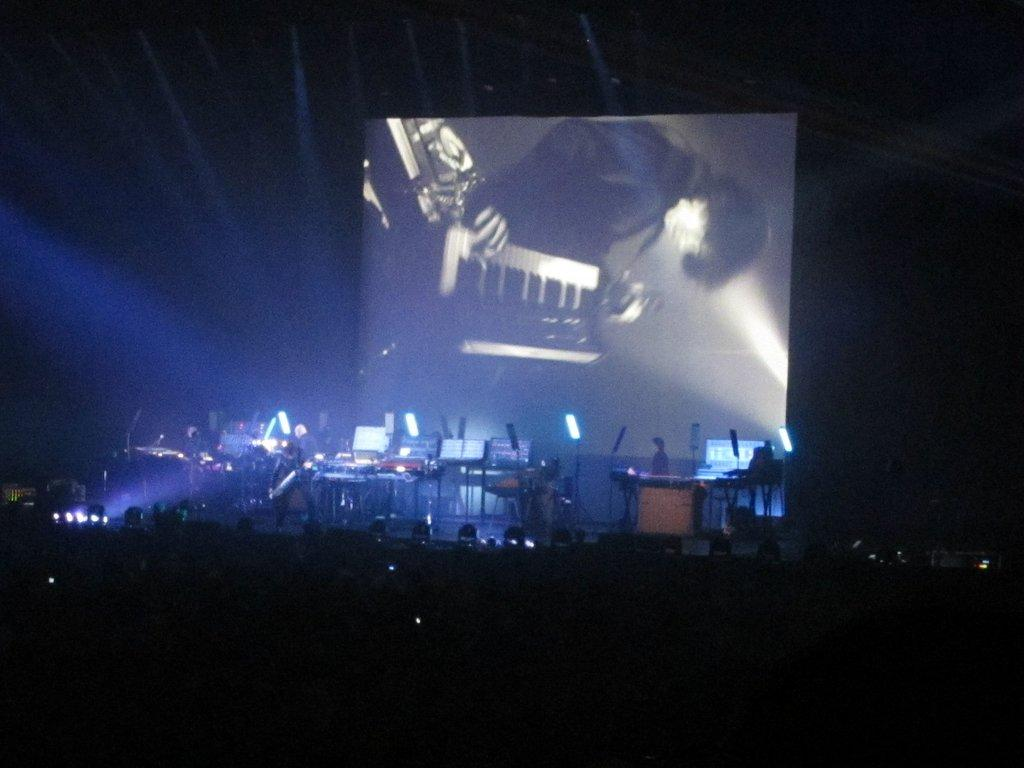What can be seen on the stage in the image? There are musical instruments on the stage in the image. Can you describe the person in the image? There is a person standing in the image. What can be seen illuminating the stage or the person? There are lights visible in the image. What is present in the background of the image? There is a screen in the background of the image. What type of van is being used for the voyage in the image? There is no van or voyage present in the image; it features a stage with musical instruments and a person. Who is the representative of the group in the image? There is no representative mentioned or depicted in the image. 